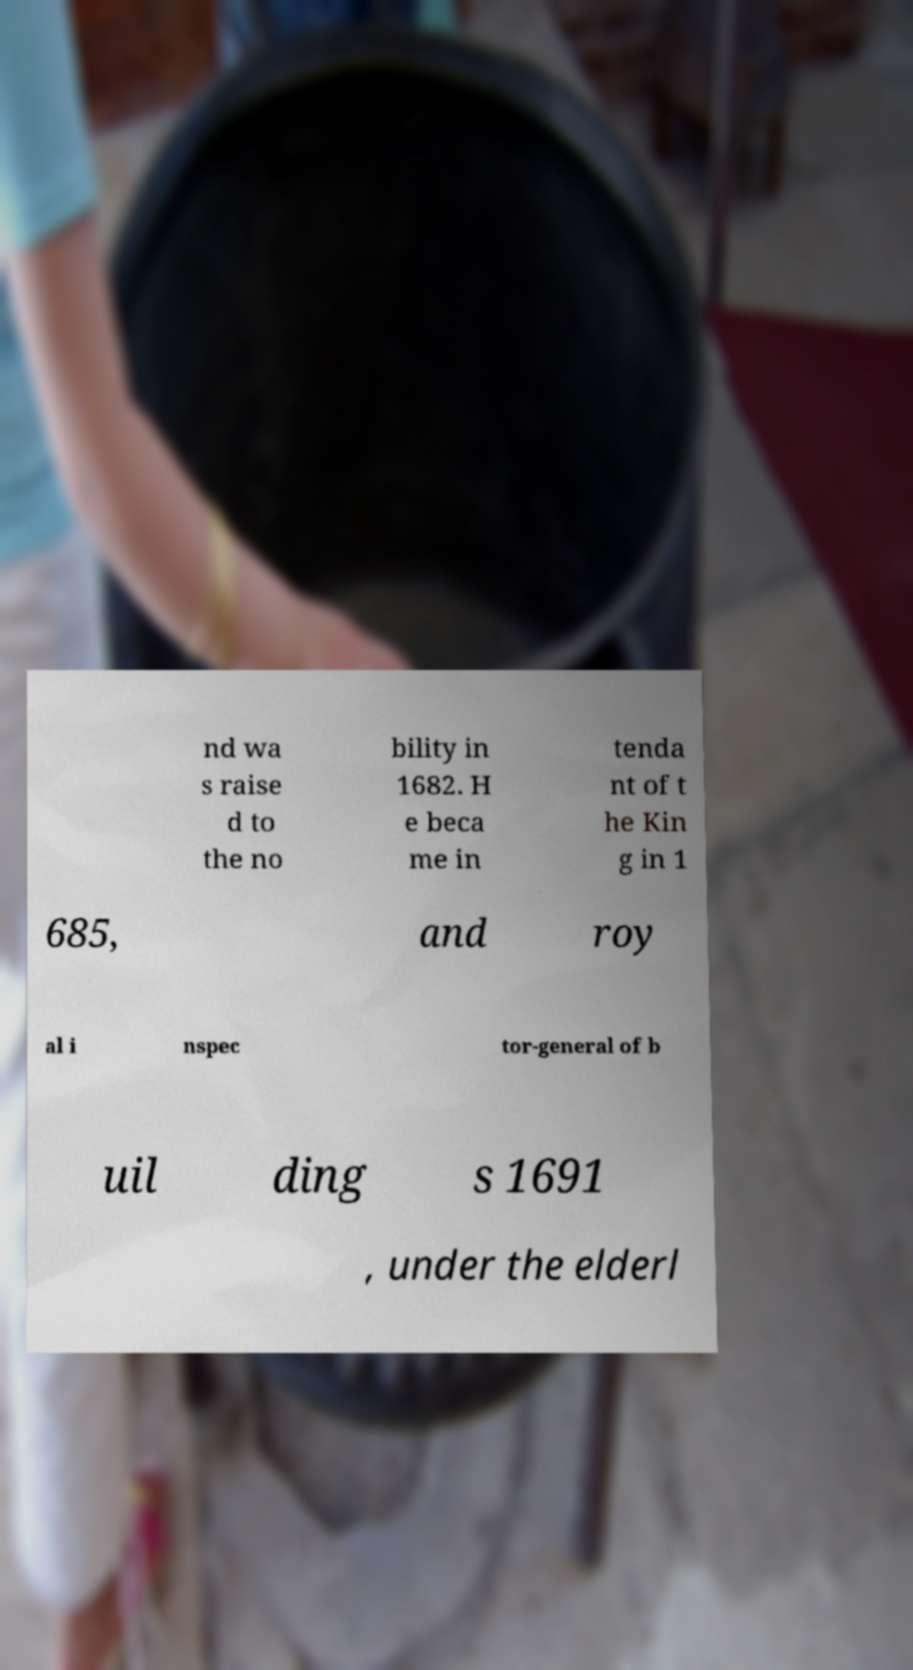Can you read and provide the text displayed in the image?This photo seems to have some interesting text. Can you extract and type it out for me? nd wa s raise d to the no bility in 1682. H e beca me in tenda nt of t he Kin g in 1 685, and roy al i nspec tor-general of b uil ding s 1691 , under the elderl 